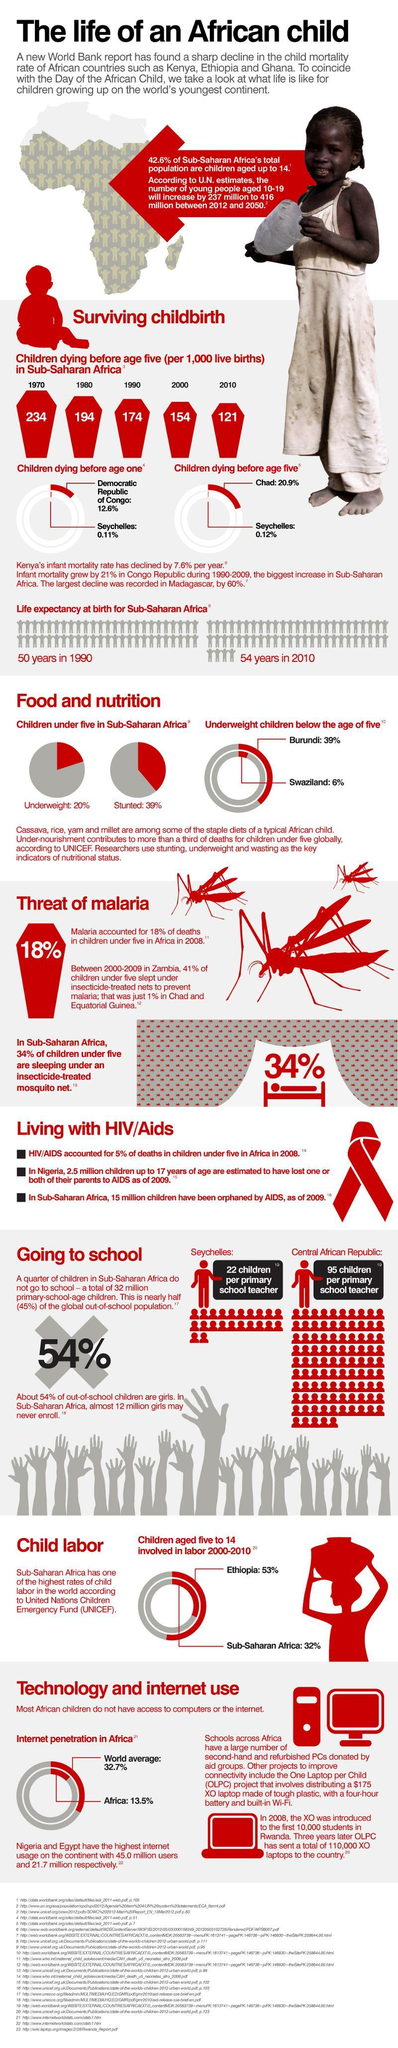What percent of Sub-Saharan African population is aged above 14?
Answer the question with a short phrase. 57.4% By what percent will the young population increase between 2012 and 2050 according to the UN estimates? 75.52% Life expectancy at birth increased to what age in 2010? 54 years Which year had the lowest number of child deaths in Sub-Saharan Africa? 2010 How many sources are given? 23 What percent of children under 5 are not underweight? 80% Which place has highest percent of children involved in labour? Ethiopia Which region had a high rate of children dying before age one? Democratic Republic of Congo 